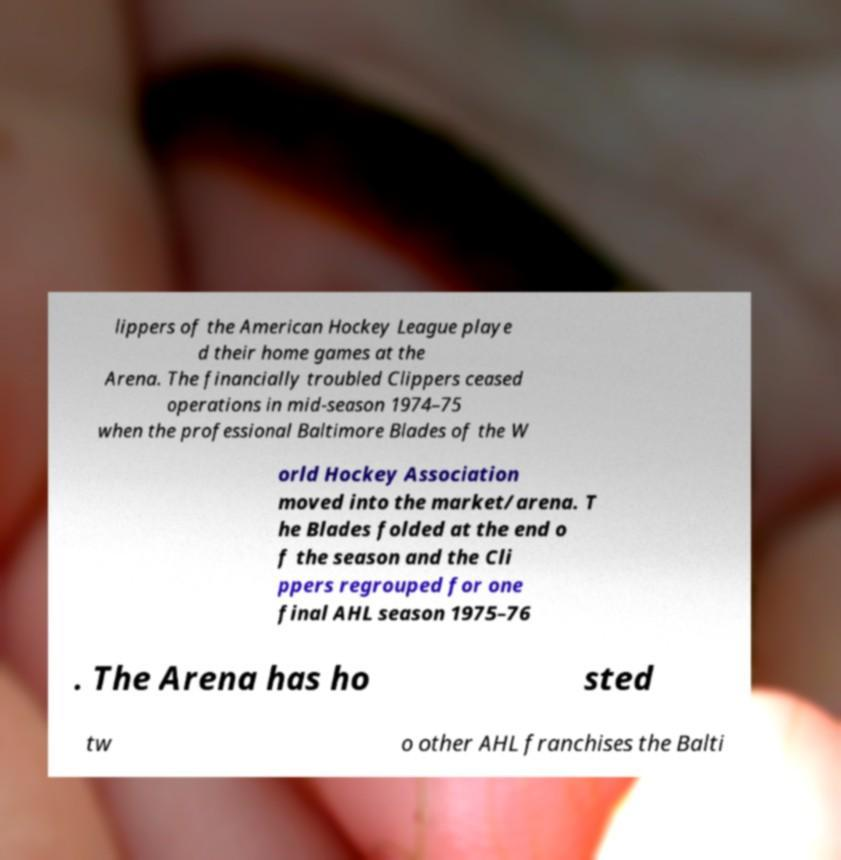Can you accurately transcribe the text from the provided image for me? lippers of the American Hockey League playe d their home games at the Arena. The financially troubled Clippers ceased operations in mid-season 1974–75 when the professional Baltimore Blades of the W orld Hockey Association moved into the market/arena. T he Blades folded at the end o f the season and the Cli ppers regrouped for one final AHL season 1975–76 . The Arena has ho sted tw o other AHL franchises the Balti 